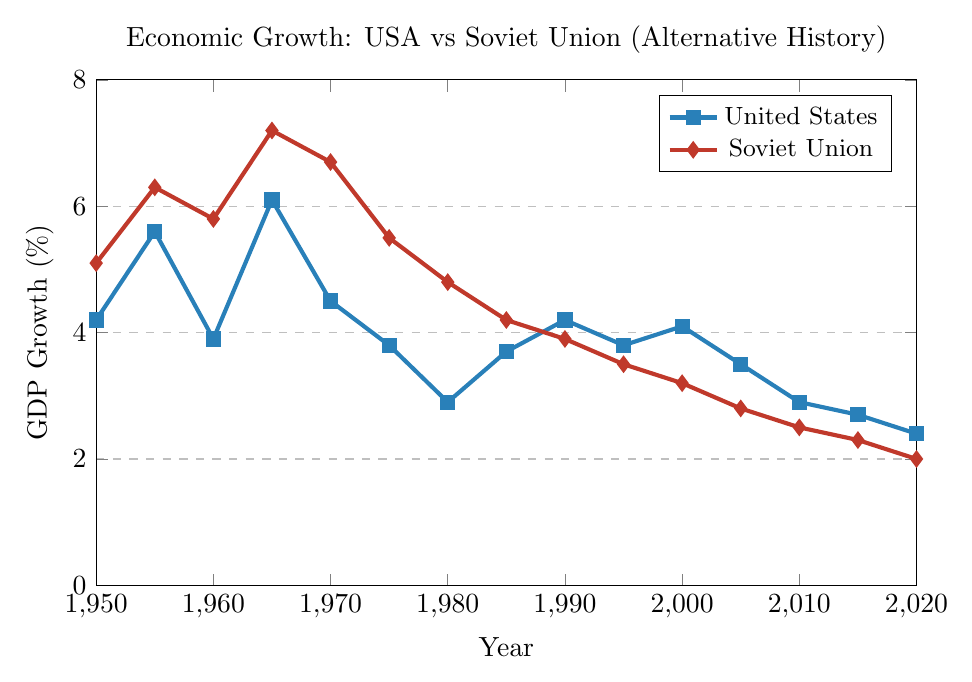What year did the Soviet Union reach its highest GDP growth rate? From the figure, the highest GDP growth rate for the Soviet Union is around 7.2%, which occurs in 1965.
Answer: 1965 In which decade did the USA experience its lowest GDP growth rate? From the figure, the lowest GDP growth rate for the USA is 2.4%, which occurs in 2020, indicating the lowest period is in the 2010s.
Answer: 2010s Between 1950 and 1970, who had a higher average GDP growth rate, the USA or the Soviet Union? To find the average, add the GDP growth rates for each country from 1950 to 1970, and then divide by the number of years. For the USA: (4.2 + 5.6 + 3.9 + 6.1 + 4.5) / 5 = 4.86. For the Soviet Union: (5.1 + 6.3 + 5.8 + 7.2 + 6.7) / 5 = 6.22. Hence, the Soviet Union had a higher average GDP growth rate in this period.
Answer: Soviet Union What is the difference in GDP growth rates between the USA and the Soviet Union in 1990? To find the difference, subtract the USA's GDP growth rate from the Soviet Union's GDP growth rate in 1990. 4.2% (USA) - 3.9% (Soviet Union) = 0.3%.
Answer: 0.3% From 1980 to 1990, did the GDP growth rate for the Soviet Union show an increasing or decreasing trend? Observing the figure from 1980 (4.8%) to 1990 (3.9%), the GDP growth rate for the Soviet Union is decreasing.
Answer: Decreasing During which year are the GDP growth rates of the USA and the Soviet Union most similar? From the figure, the GDP growth rates of the USA and the Soviet Union are closest in 1990, where the USA has a rate of 4.2% and the Soviet Union has a rate of 3.9%.
Answer: 1990 Which country had a higher GDP growth rate in 2005 and by how much? The figure shows the GDP growth rate for the USA in 2005 is 3.5% and for the Soviet Union, it's 2.8%. The difference is 3.5% - 2.8% = 0.7%.
Answer: USA by 0.7% By 2020, how much did the GDP growth rate of the Soviet Union decline compared to its peak in 1965? The peak GDP growth rate for the Soviet Union is 7.2% in 1965, and by 2020, it is 2%. The decline is 7.2% - 2% = 5.2%.
Answer: 5.2% What is the overall trend in GDP growth rates for both the USA and the Soviet Union from 1950 to 2020? The figure displays a general declining trend in GDP growth rates for both the USA and the Soviet Union from 1950 (4.2% USA, 5.1% Soviet Union) to 2020 (2.4% USA, 2.0% Soviet Union).
Answer: Declining 